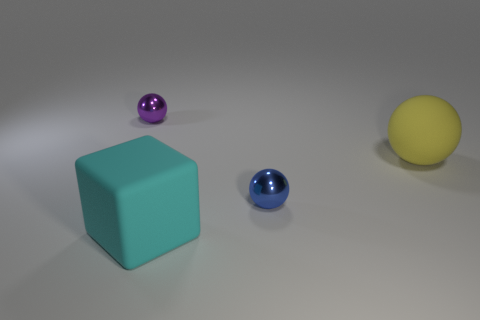There is a small blue thing that is the same shape as the big yellow thing; what is its material?
Your response must be concise. Metal. There is a small thing that is to the right of the thing on the left side of the big cube; is there a matte sphere to the left of it?
Make the answer very short. No. There is a blue ball; how many purple things are in front of it?
Your answer should be compact. 0. How many other big cubes are the same color as the block?
Provide a succinct answer. 0. How many objects are either big things behind the small blue thing or shiny objects on the right side of the purple ball?
Offer a very short reply. 2. Are there more big rubber things than big cyan rubber cubes?
Keep it short and to the point. Yes. What is the color of the ball on the left side of the cyan block?
Make the answer very short. Purple. Is the yellow matte object the same shape as the small purple thing?
Offer a very short reply. Yes. What color is the thing that is behind the blue shiny object and to the left of the blue metal object?
Your answer should be compact. Purple. Is the size of the rubber thing in front of the large yellow matte thing the same as the shiny ball on the right side of the purple metal object?
Keep it short and to the point. No. 